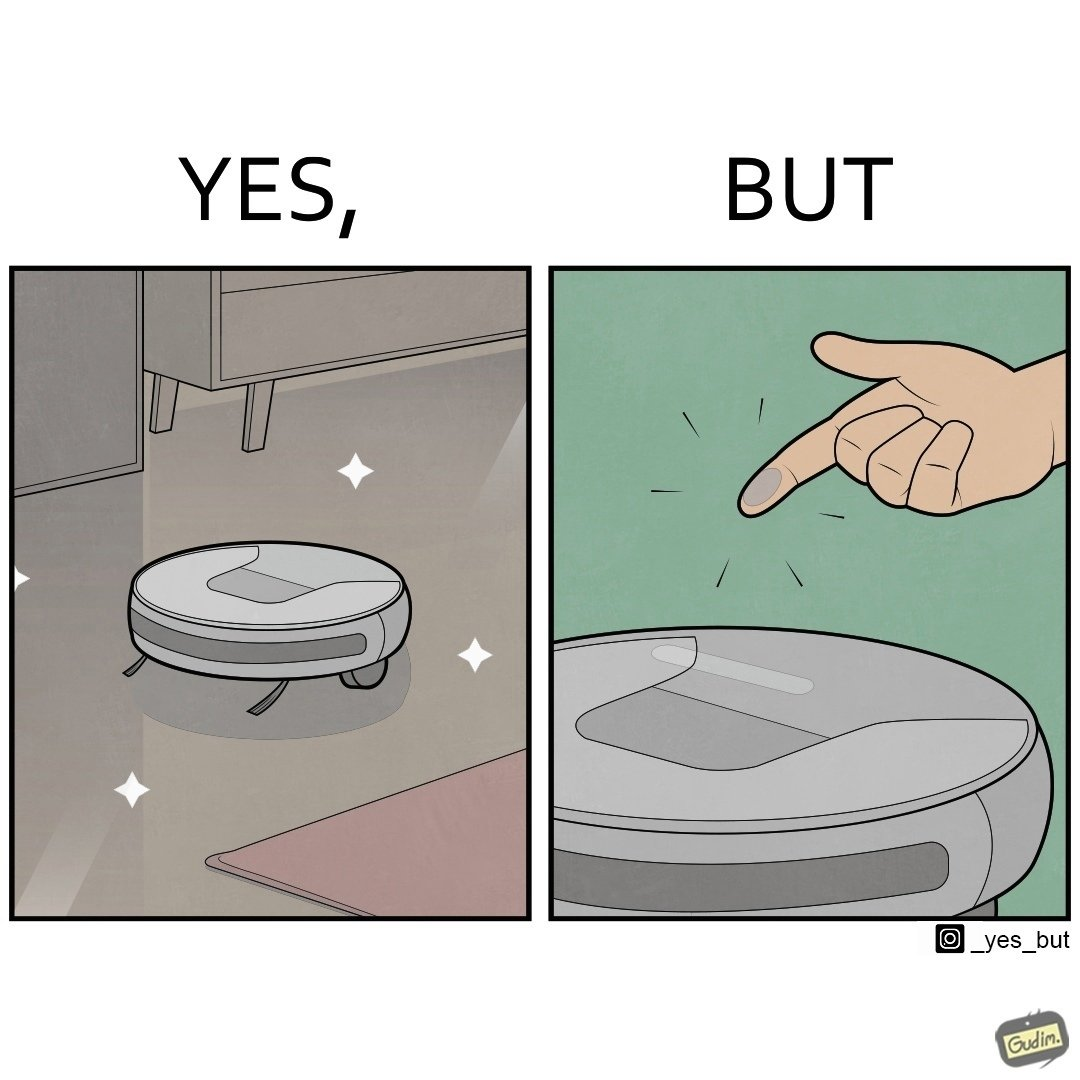What does this image depict? This is funny, because the machine while doing its job cleans everything but ends up being dirty itself. 